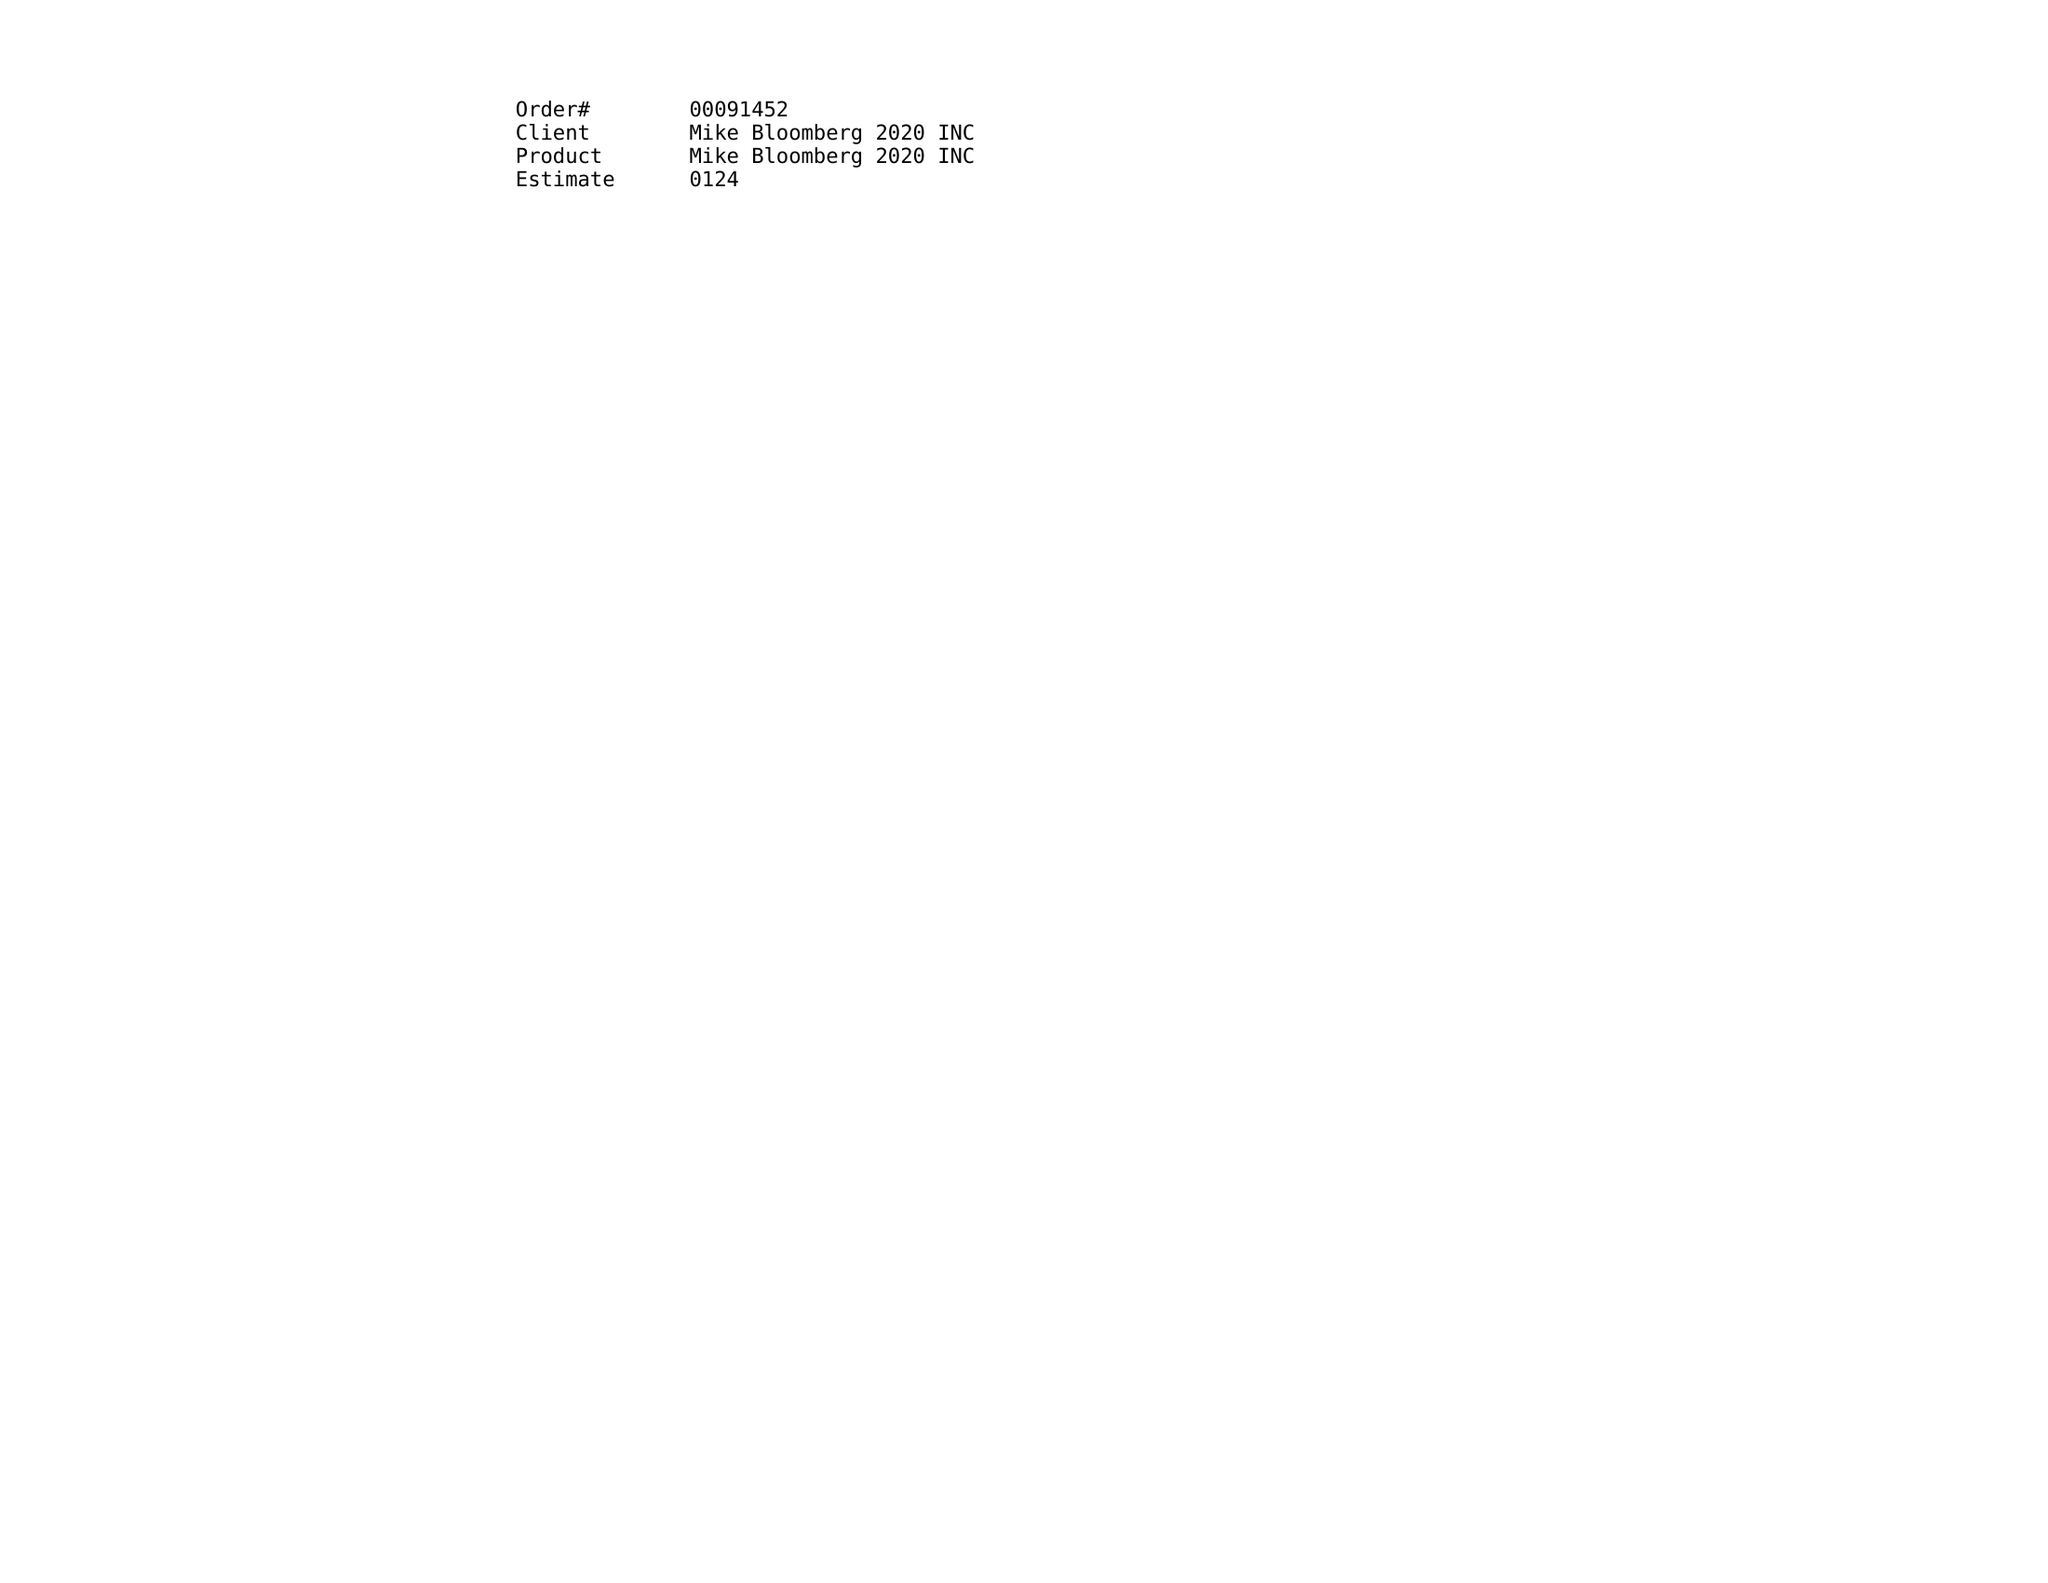What is the value for the flight_to?
Answer the question using a single word or phrase. 03/29/20 